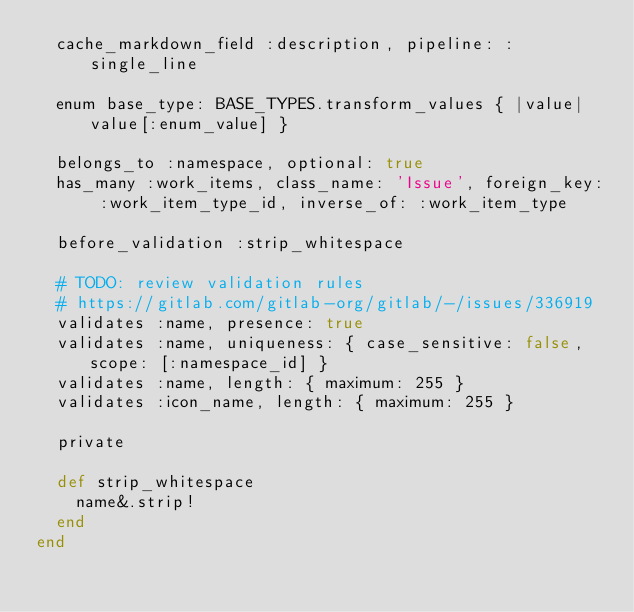<code> <loc_0><loc_0><loc_500><loc_500><_Ruby_>  cache_markdown_field :description, pipeline: :single_line

  enum base_type: BASE_TYPES.transform_values { |value| value[:enum_value] }

  belongs_to :namespace, optional: true
  has_many :work_items, class_name: 'Issue', foreign_key: :work_item_type_id, inverse_of: :work_item_type

  before_validation :strip_whitespace

  # TODO: review validation rules
  # https://gitlab.com/gitlab-org/gitlab/-/issues/336919
  validates :name, presence: true
  validates :name, uniqueness: { case_sensitive: false, scope: [:namespace_id] }
  validates :name, length: { maximum: 255 }
  validates :icon_name, length: { maximum: 255 }

  private

  def strip_whitespace
    name&.strip!
  end
end
</code> 